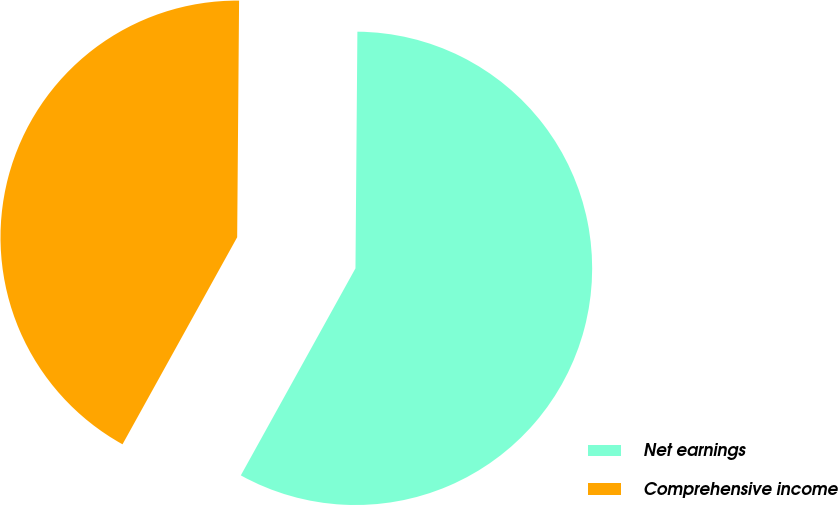Convert chart to OTSL. <chart><loc_0><loc_0><loc_500><loc_500><pie_chart><fcel>Net earnings<fcel>Comprehensive income<nl><fcel>57.92%<fcel>42.08%<nl></chart> 